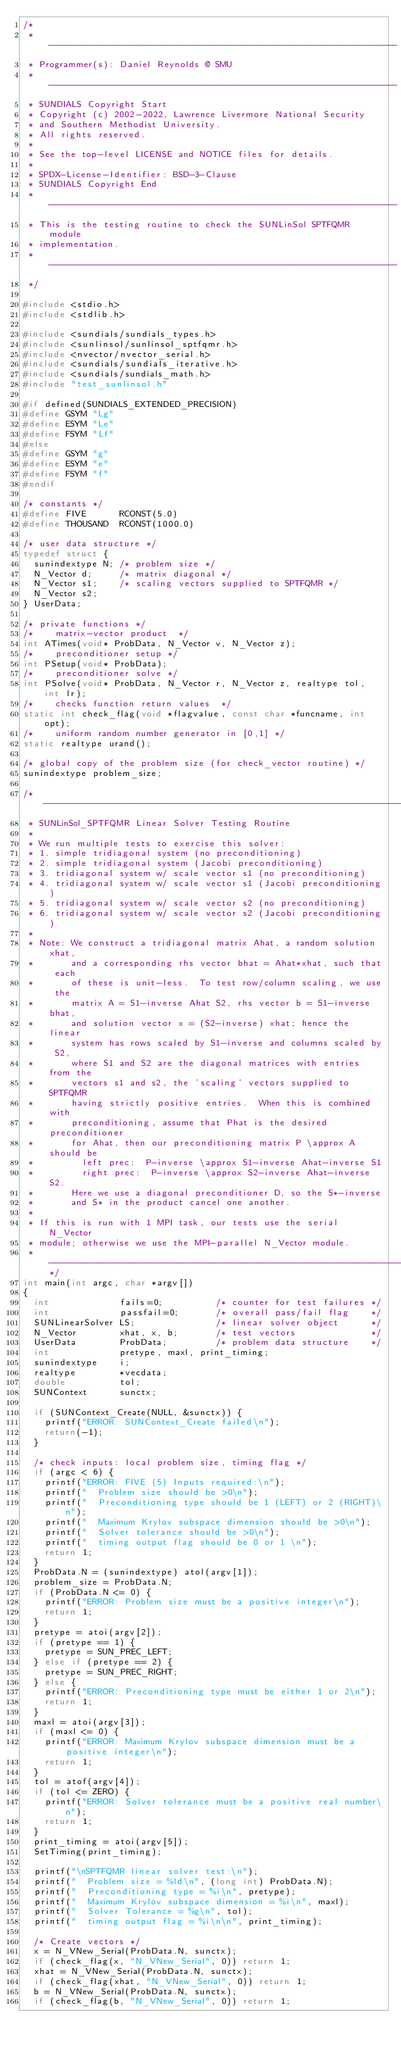<code> <loc_0><loc_0><loc_500><loc_500><_C_>/*
 * -----------------------------------------------------------------
 * Programmer(s): Daniel Reynolds @ SMU
 * -----------------------------------------------------------------
 * SUNDIALS Copyright Start
 * Copyright (c) 2002-2022, Lawrence Livermore National Security
 * and Southern Methodist University.
 * All rights reserved.
 *
 * See the top-level LICENSE and NOTICE files for details.
 *
 * SPDX-License-Identifier: BSD-3-Clause
 * SUNDIALS Copyright End
 * -----------------------------------------------------------------
 * This is the testing routine to check the SUNLinSol SPTFQMR module
 * implementation.
 * -----------------------------------------------------------------
 */

#include <stdio.h>
#include <stdlib.h>

#include <sundials/sundials_types.h>
#include <sunlinsol/sunlinsol_sptfqmr.h>
#include <nvector/nvector_serial.h>
#include <sundials/sundials_iterative.h>
#include <sundials/sundials_math.h>
#include "test_sunlinsol.h"

#if defined(SUNDIALS_EXTENDED_PRECISION)
#define GSYM "Lg"
#define ESYM "Le"
#define FSYM "Lf"
#else
#define GSYM "g"
#define ESYM "e"
#define FSYM "f"
#endif

/* constants */
#define FIVE      RCONST(5.0)
#define THOUSAND  RCONST(1000.0)

/* user data structure */
typedef struct {
  sunindextype N; /* problem size */
  N_Vector d;     /* matrix diagonal */
  N_Vector s1;    /* scaling vectors supplied to SPTFQMR */
  N_Vector s2;
} UserData;

/* private functions */
/*    matrix-vector product  */
int ATimes(void* ProbData, N_Vector v, N_Vector z);
/*    preconditioner setup */
int PSetup(void* ProbData);
/*    preconditioner solve */
int PSolve(void* ProbData, N_Vector r, N_Vector z, realtype tol, int lr);
/*    checks function return values  */
static int check_flag(void *flagvalue, const char *funcname, int opt);
/*    uniform random number generator in [0,1] */
static realtype urand();

/* global copy of the problem size (for check_vector routine) */
sunindextype problem_size;

/* ----------------------------------------------------------------------
 * SUNLinSol_SPTFQMR Linear Solver Testing Routine
 *
 * We run multiple tests to exercise this solver:
 * 1. simple tridiagonal system (no preconditioning)
 * 2. simple tridiagonal system (Jacobi preconditioning)
 * 3. tridiagonal system w/ scale vector s1 (no preconditioning)
 * 4. tridiagonal system w/ scale vector s1 (Jacobi preconditioning)
 * 5. tridiagonal system w/ scale vector s2 (no preconditioning)
 * 6. tridiagonal system w/ scale vector s2 (Jacobi preconditioning)
 *
 * Note: We construct a tridiagonal matrix Ahat, a random solution xhat,
 *       and a corresponding rhs vector bhat = Ahat*xhat, such that each
 *       of these is unit-less.  To test row/column scaling, we use the
 *       matrix A = S1-inverse Ahat S2, rhs vector b = S1-inverse bhat,
 *       and solution vector x = (S2-inverse) xhat; hence the linear
 *       system has rows scaled by S1-inverse and columns scaled by S2,
 *       where S1 and S2 are the diagonal matrices with entries from the
 *       vectors s1 and s2, the 'scaling' vectors supplied to SPTFQMR
 *       having strictly positive entries.  When this is combined with
 *       preconditioning, assume that Phat is the desired preconditioner
 *       for Ahat, then our preconditioning matrix P \approx A should be
 *         left prec:  P-inverse \approx S1-inverse Ahat-inverse S1
 *         right prec:  P-inverse \approx S2-inverse Ahat-inverse S2.
 *       Here we use a diagonal preconditioner D, so the S*-inverse
 *       and S* in the product cancel one another.
 *
 * If this is run with 1 MPI task, our tests use the serial N_Vector
 * module; otherwise we use the MPI-parallel N_Vector module.
 * --------------------------------------------------------------------*/
int main(int argc, char *argv[])
{
  int             fails=0;          /* counter for test failures */
  int             passfail=0;       /* overall pass/fail flag    */
  SUNLinearSolver LS;               /* linear solver object      */
  N_Vector        xhat, x, b;       /* test vectors              */
  UserData        ProbData;         /* problem data structure    */
  int             pretype, maxl, print_timing;
  sunindextype    i;
  realtype        *vecdata;
  double          tol;
  SUNContext      sunctx;

  if (SUNContext_Create(NULL, &sunctx)) {
    printf("ERROR: SUNContext_Create failed\n");
    return(-1);
  }

  /* check inputs: local problem size, timing flag */
  if (argc < 6) {
    printf("ERROR: FIVE (5) Inputs required:\n");
    printf("  Problem size should be >0\n");
    printf("  Preconditioning type should be 1 (LEFT) or 2 (RIGHT)\n");
    printf("  Maximum Krylov subspace dimension should be >0\n");
    printf("  Solver tolerance should be >0\n");
    printf("  timing output flag should be 0 or 1 \n");
    return 1;
  }
  ProbData.N = (sunindextype) atol(argv[1]);
  problem_size = ProbData.N;
  if (ProbData.N <= 0) {
    printf("ERROR: Problem size must be a positive integer\n");
    return 1;
  }
  pretype = atoi(argv[2]);
  if (pretype == 1) {
    pretype = SUN_PREC_LEFT;
  } else if (pretype == 2) {
    pretype = SUN_PREC_RIGHT;
  } else {
    printf("ERROR: Preconditioning type must be either 1 or 2\n");
    return 1;
  }
  maxl = atoi(argv[3]);
  if (maxl <= 0) {
    printf("ERROR: Maximum Krylov subspace dimension must be a positive integer\n");
    return 1;
  }
  tol = atof(argv[4]);
  if (tol <= ZERO) {
    printf("ERROR: Solver tolerance must be a positive real number\n");
    return 1;
  }
  print_timing = atoi(argv[5]);
  SetTiming(print_timing);

  printf("\nSPTFQMR linear solver test:\n");
  printf("  Problem size = %ld\n", (long int) ProbData.N);
  printf("  Preconditioning type = %i\n", pretype);
  printf("  Maximum Krylov subspace dimension = %i\n", maxl);
  printf("  Solver Tolerance = %g\n", tol);
  printf("  timing output flag = %i\n\n", print_timing);

  /* Create vectors */
  x = N_VNew_Serial(ProbData.N, sunctx);
  if (check_flag(x, "N_VNew_Serial", 0)) return 1;
  xhat = N_VNew_Serial(ProbData.N, sunctx);
  if (check_flag(xhat, "N_VNew_Serial", 0)) return 1;
  b = N_VNew_Serial(ProbData.N, sunctx);
  if (check_flag(b, "N_VNew_Serial", 0)) return 1;</code> 